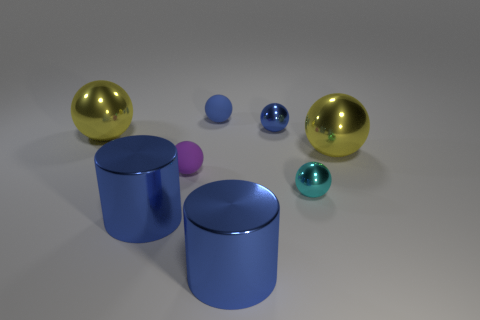Is the material of the big yellow ball that is to the left of the small purple matte sphere the same as the tiny cyan object?
Give a very brief answer. Yes. How many other things are there of the same shape as the cyan thing?
Make the answer very short. 5. There is a ball that is behind the tiny shiny ball that is left of the cyan shiny sphere; what number of metal cylinders are behind it?
Give a very brief answer. 0. The sphere that is to the right of the cyan metallic thing is what color?
Your answer should be compact. Yellow. What size is the blue matte object that is the same shape as the purple matte object?
Provide a short and direct response. Small. What is the material of the tiny thing on the left side of the matte object that is right of the purple sphere behind the cyan thing?
Your answer should be very brief. Rubber. Is the number of purple balls that are left of the tiny blue metal sphere greater than the number of tiny matte spheres that are right of the blue matte ball?
Ensure brevity in your answer.  Yes. What is the color of the other small metallic thing that is the same shape as the cyan metallic object?
Your answer should be very brief. Blue. Is the number of tiny blue shiny balls behind the tiny purple sphere greater than the number of large red blocks?
Offer a very short reply. Yes. What color is the small metal object that is to the right of the blue shiny thing that is behind the tiny purple ball?
Keep it short and to the point. Cyan. 